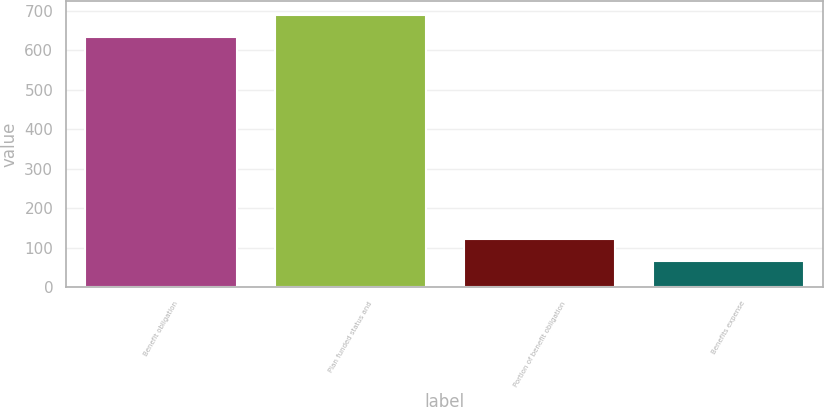<chart> <loc_0><loc_0><loc_500><loc_500><bar_chart><fcel>Benefit obligation<fcel>Plan funded status and<fcel>Portion of benefit obligation<fcel>Benefits expense<nl><fcel>633<fcel>689.8<fcel>121.8<fcel>65<nl></chart> 